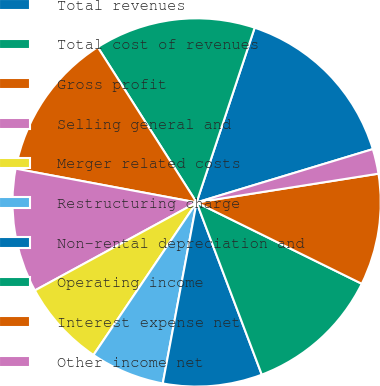Convert chart. <chart><loc_0><loc_0><loc_500><loc_500><pie_chart><fcel>Total revenues<fcel>Total cost of revenues<fcel>Gross profit<fcel>Selling general and<fcel>Merger related costs<fcel>Restructuring charge<fcel>Non-rental depreciation and<fcel>Operating income<fcel>Interest expense net<fcel>Other income net<nl><fcel>15.22%<fcel>14.13%<fcel>13.04%<fcel>10.87%<fcel>7.61%<fcel>6.52%<fcel>8.7%<fcel>11.96%<fcel>9.78%<fcel>2.18%<nl></chart> 